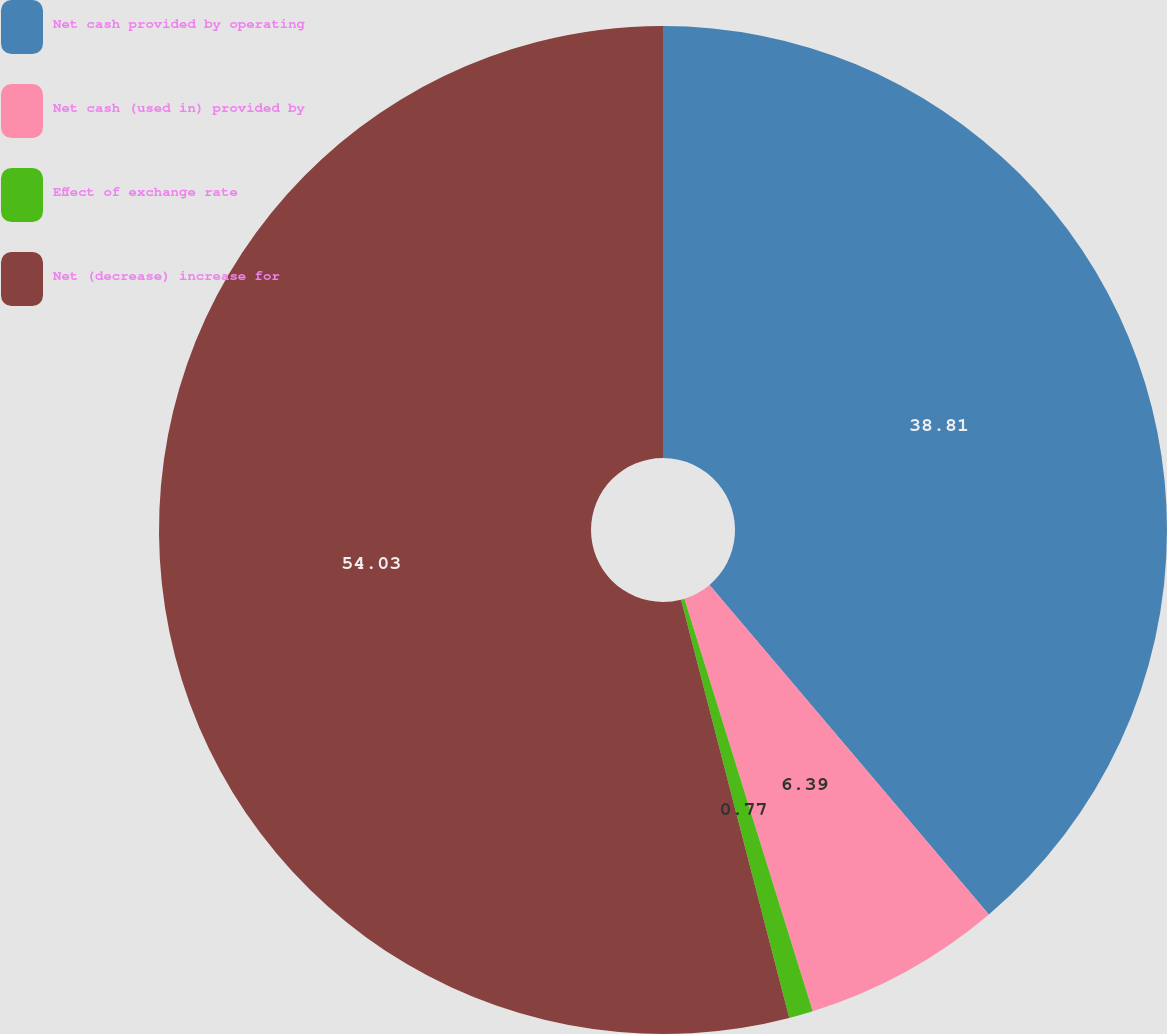Convert chart. <chart><loc_0><loc_0><loc_500><loc_500><pie_chart><fcel>Net cash provided by operating<fcel>Net cash (used in) provided by<fcel>Effect of exchange rate<fcel>Net (decrease) increase for<nl><fcel>38.81%<fcel>6.39%<fcel>0.77%<fcel>54.03%<nl></chart> 